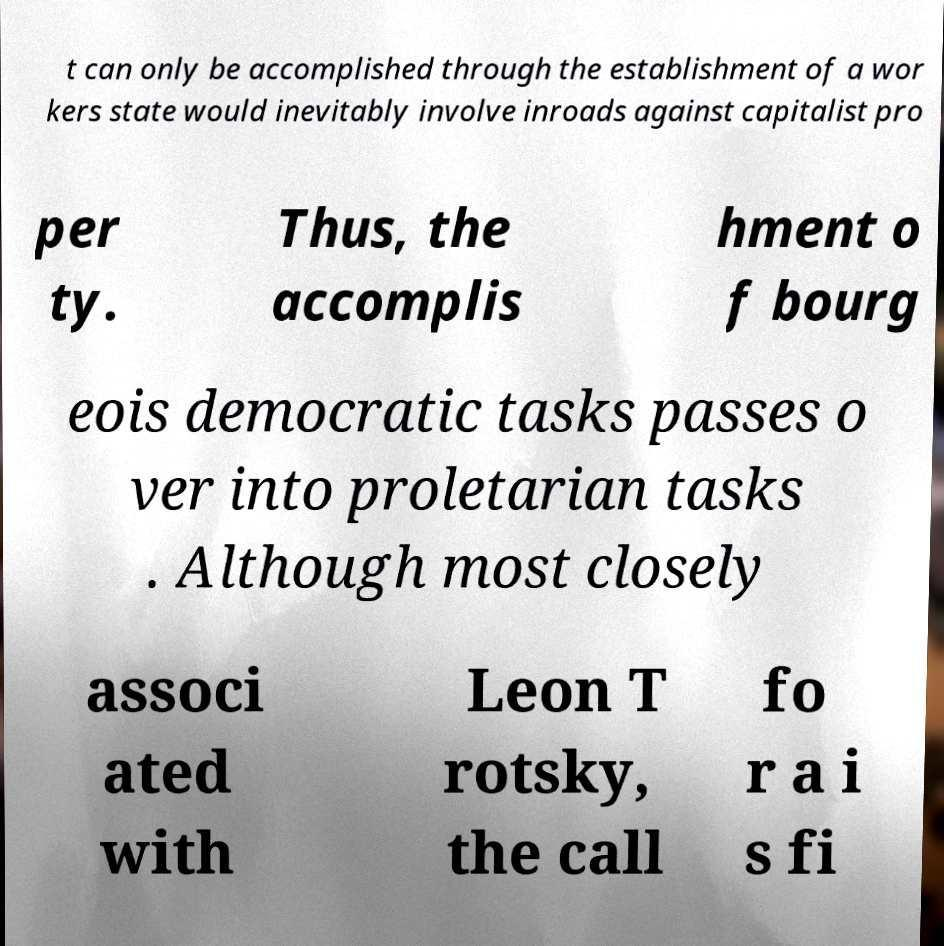Could you extract and type out the text from this image? t can only be accomplished through the establishment of a wor kers state would inevitably involve inroads against capitalist pro per ty. Thus, the accomplis hment o f bourg eois democratic tasks passes o ver into proletarian tasks . Although most closely associ ated with Leon T rotsky, the call fo r a i s fi 